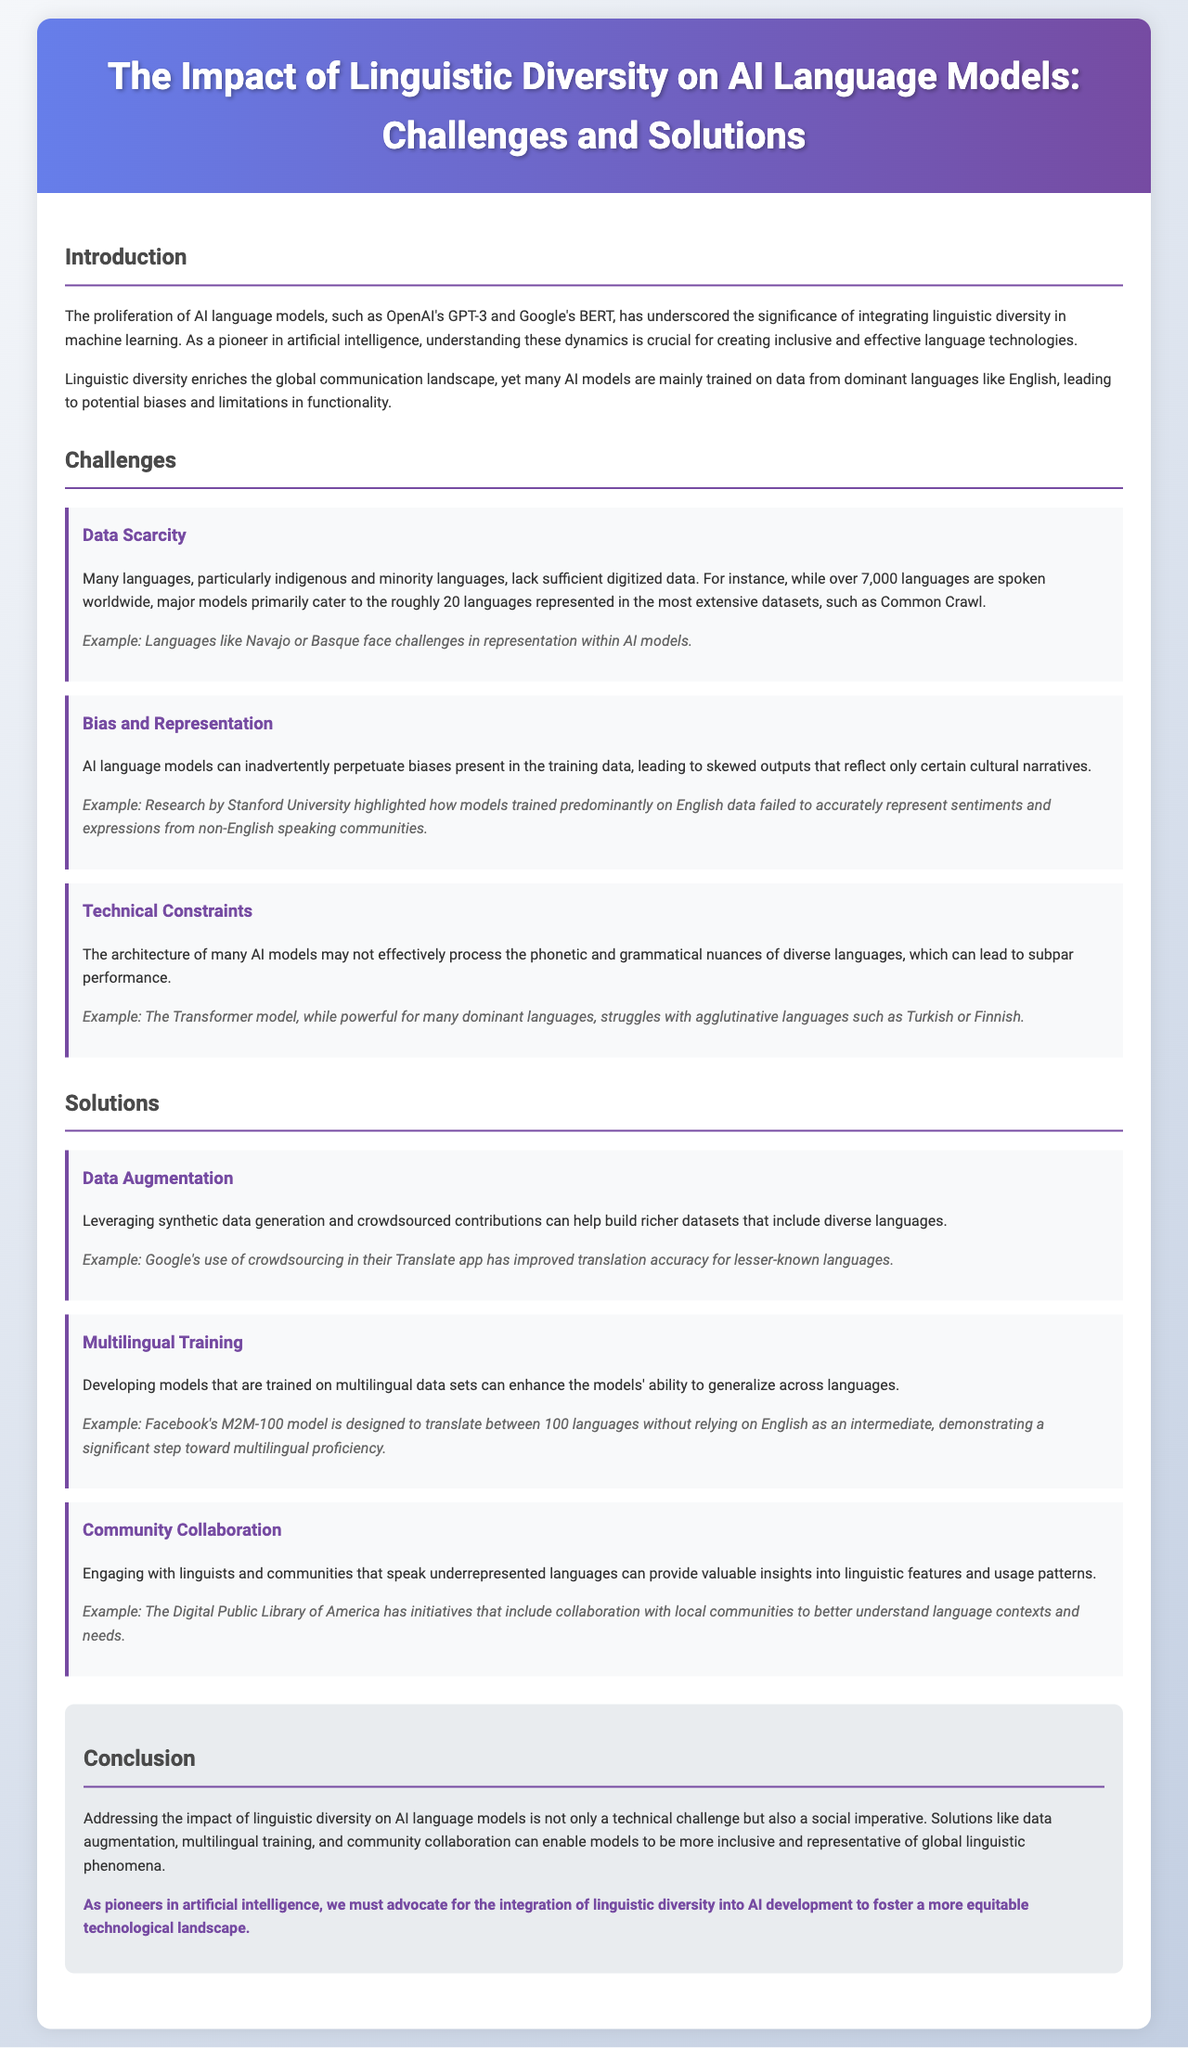What is the title of the report? The title of the report is the main heading of the document, which summarizes its focus on linguistic diversity in AI.
Answer: The Impact of Linguistic Diversity on AI Language Models: Challenges and Solutions How many languages are spoken worldwide? The document mentions that there are over 7,000 languages spoken worldwide.
Answer: over 7,000 What is one example of a language facing representation challenges? The report provides specific examples of languages lacking representation in AI.
Answer: Navajo Which AI model is designed to translate between 100 languages? The document cites a specific model that showcases advancements in multilingual capabilities.
Answer: Facebook's M2M-100 What is a suggested solution for improving linguistic data representation? The report proposes various strategies to enhance language inclusion in AI.
Answer: Data Augmentation What is highlighted as a social imperative in the conclusion? The conclusion emphasizes a particular importance related to linguistic diversity in AI development.
Answer: social imperative What is one technical constraint mentioned regarding AI language models? The document lists limitations that AI models face with certain linguistic features.
Answer: phonetic and grammatical nuances Which organization's initiative involves community collaboration for better understanding language needs? The report references a specific organization that actively engages with local communities for insights.
Answer: Digital Public Library of America What do we need to advocate for according to the conclusion? The conclusion reiterates a key call to action for improving language representation in AI.
Answer: integration of linguistic diversity 